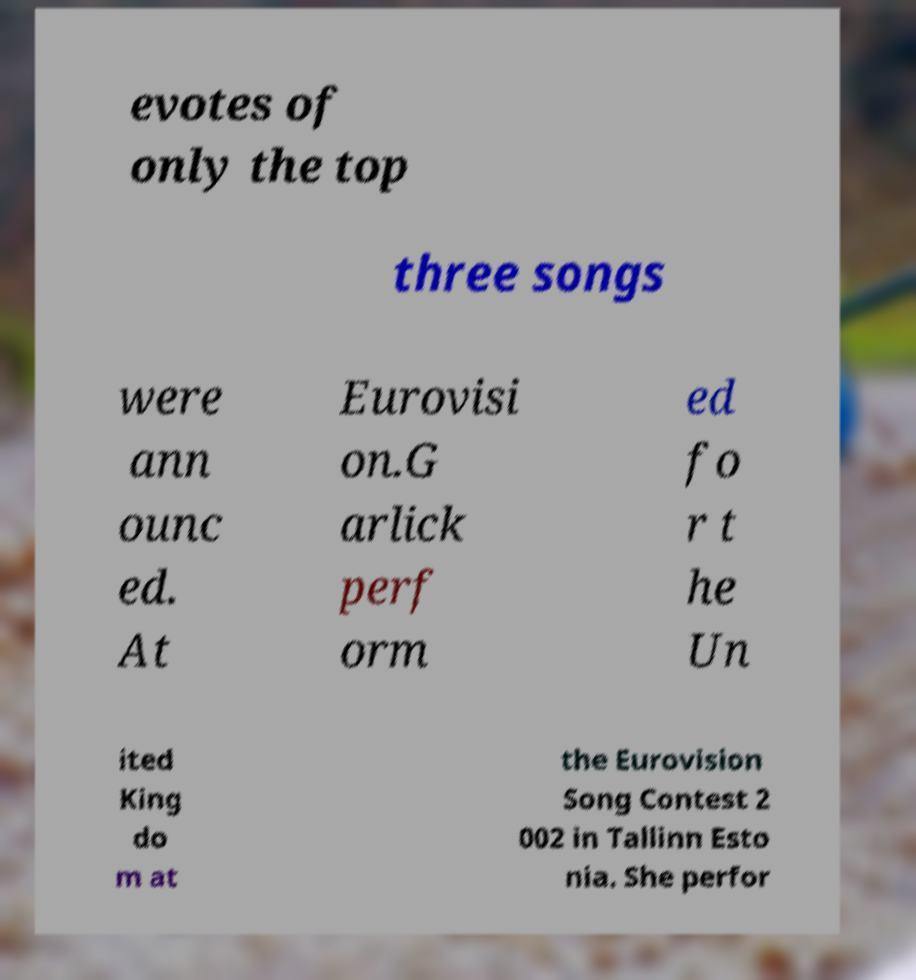What messages or text are displayed in this image? I need them in a readable, typed format. evotes of only the top three songs were ann ounc ed. At Eurovisi on.G arlick perf orm ed fo r t he Un ited King do m at the Eurovision Song Contest 2 002 in Tallinn Esto nia. She perfor 